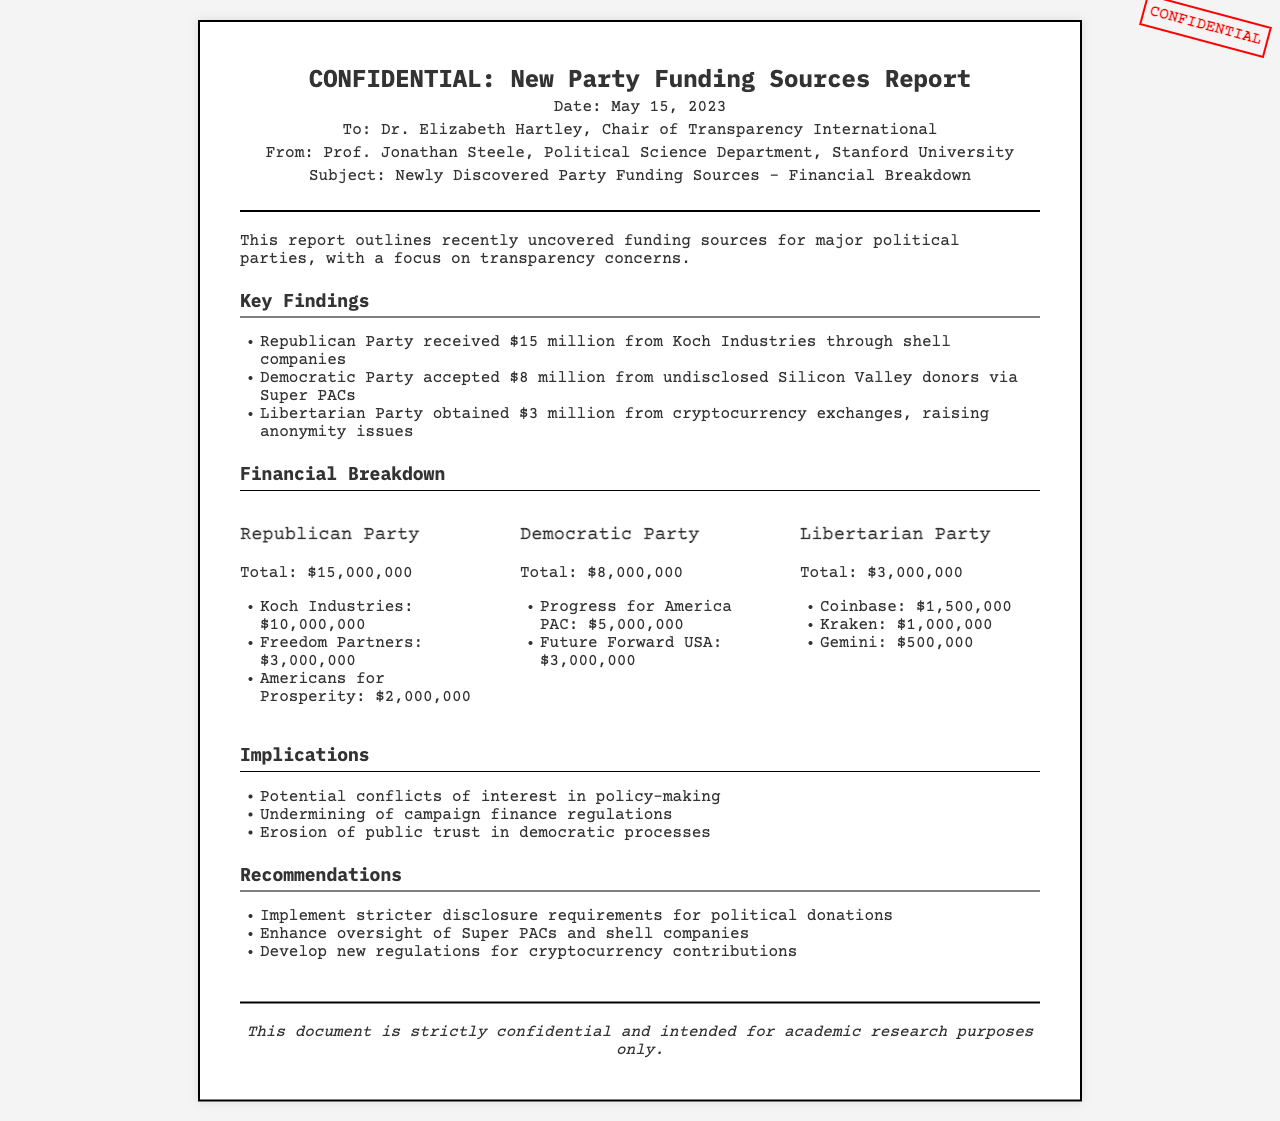What is the total funding received by the Republican Party? The total funding for the Republican Party is explicitly stated in the document as $15,000,000.
Answer: $15,000,000 From which company did the Democratic Party receive the highest funding? The highest funding source for the Democratic Party is Progress for America PAC, which contributed $5,000,000.
Answer: Progress for America PAC How much did cryptocurrency exchanges contribute to the Libertarian Party? The total contribution from cryptocurrency exchanges to the Libertarian Party is mentioned as $3,000,000.
Answer: $3,000,000 What are the recommendations given in the report? The report provides three recommendations, clearly outlined in a section, such as implementing stricter disclosure requirements.
Answer: Implement stricter disclosure requirements for political donations What is the date of the report? The date of the report is documented at the top section and is May 15, 2023.
Answer: May 15, 2023 What does the report highlight regarding potential issues? The report outlines several implications, including potential conflicts of interest in policy-making.
Answer: Potential conflicts of interest in policy-making How many financial contributors are listed for the Democratic Party? The financial breakdown section shows that there are two contributors listed for the Democratic Party.
Answer: 2 What confidential label is printed on the document? The document prominently features the word "CONFIDENTIAL" in red at the top right corner, indicating its sensitivity.
Answer: CONFIDENTIAL What is one issue raised in the implications section? The implications section mentions that the funding sources could lead to an erosion of public trust in democratic processes.
Answer: Erosion of public trust in democratic processes 